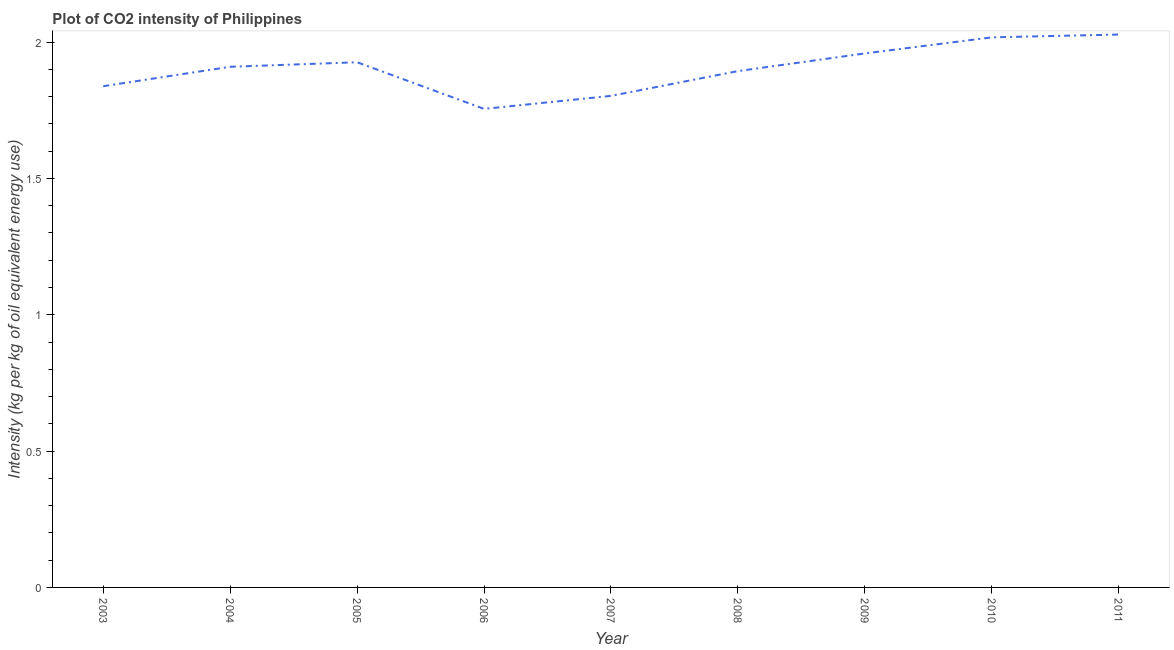What is the co2 intensity in 2010?
Your response must be concise. 2.02. Across all years, what is the maximum co2 intensity?
Make the answer very short. 2.03. Across all years, what is the minimum co2 intensity?
Offer a terse response. 1.76. In which year was the co2 intensity maximum?
Your response must be concise. 2011. In which year was the co2 intensity minimum?
Keep it short and to the point. 2006. What is the sum of the co2 intensity?
Make the answer very short. 17.13. What is the difference between the co2 intensity in 2003 and 2008?
Keep it short and to the point. -0.06. What is the average co2 intensity per year?
Make the answer very short. 1.9. What is the median co2 intensity?
Keep it short and to the point. 1.91. In how many years, is the co2 intensity greater than 0.4 kg?
Your response must be concise. 9. What is the ratio of the co2 intensity in 2003 to that in 2008?
Offer a terse response. 0.97. Is the difference between the co2 intensity in 2005 and 2006 greater than the difference between any two years?
Your response must be concise. No. What is the difference between the highest and the second highest co2 intensity?
Make the answer very short. 0.01. What is the difference between the highest and the lowest co2 intensity?
Make the answer very short. 0.27. In how many years, is the co2 intensity greater than the average co2 intensity taken over all years?
Your response must be concise. 5. Does the co2 intensity monotonically increase over the years?
Offer a terse response. No. Are the values on the major ticks of Y-axis written in scientific E-notation?
Offer a very short reply. No. Does the graph contain grids?
Your response must be concise. No. What is the title of the graph?
Your response must be concise. Plot of CO2 intensity of Philippines. What is the label or title of the X-axis?
Offer a terse response. Year. What is the label or title of the Y-axis?
Make the answer very short. Intensity (kg per kg of oil equivalent energy use). What is the Intensity (kg per kg of oil equivalent energy use) of 2003?
Make the answer very short. 1.84. What is the Intensity (kg per kg of oil equivalent energy use) of 2004?
Provide a short and direct response. 1.91. What is the Intensity (kg per kg of oil equivalent energy use) of 2005?
Give a very brief answer. 1.93. What is the Intensity (kg per kg of oil equivalent energy use) in 2006?
Offer a terse response. 1.76. What is the Intensity (kg per kg of oil equivalent energy use) of 2007?
Offer a terse response. 1.8. What is the Intensity (kg per kg of oil equivalent energy use) of 2008?
Provide a succinct answer. 1.89. What is the Intensity (kg per kg of oil equivalent energy use) in 2009?
Your answer should be very brief. 1.96. What is the Intensity (kg per kg of oil equivalent energy use) in 2010?
Provide a succinct answer. 2.02. What is the Intensity (kg per kg of oil equivalent energy use) of 2011?
Offer a terse response. 2.03. What is the difference between the Intensity (kg per kg of oil equivalent energy use) in 2003 and 2004?
Your answer should be compact. -0.07. What is the difference between the Intensity (kg per kg of oil equivalent energy use) in 2003 and 2005?
Make the answer very short. -0.09. What is the difference between the Intensity (kg per kg of oil equivalent energy use) in 2003 and 2006?
Your answer should be compact. 0.08. What is the difference between the Intensity (kg per kg of oil equivalent energy use) in 2003 and 2007?
Your answer should be compact. 0.04. What is the difference between the Intensity (kg per kg of oil equivalent energy use) in 2003 and 2008?
Provide a succinct answer. -0.06. What is the difference between the Intensity (kg per kg of oil equivalent energy use) in 2003 and 2009?
Offer a terse response. -0.12. What is the difference between the Intensity (kg per kg of oil equivalent energy use) in 2003 and 2010?
Your answer should be very brief. -0.18. What is the difference between the Intensity (kg per kg of oil equivalent energy use) in 2003 and 2011?
Provide a succinct answer. -0.19. What is the difference between the Intensity (kg per kg of oil equivalent energy use) in 2004 and 2005?
Your response must be concise. -0.02. What is the difference between the Intensity (kg per kg of oil equivalent energy use) in 2004 and 2006?
Your answer should be very brief. 0.15. What is the difference between the Intensity (kg per kg of oil equivalent energy use) in 2004 and 2007?
Your answer should be very brief. 0.11. What is the difference between the Intensity (kg per kg of oil equivalent energy use) in 2004 and 2008?
Your response must be concise. 0.02. What is the difference between the Intensity (kg per kg of oil equivalent energy use) in 2004 and 2009?
Keep it short and to the point. -0.05. What is the difference between the Intensity (kg per kg of oil equivalent energy use) in 2004 and 2010?
Your response must be concise. -0.11. What is the difference between the Intensity (kg per kg of oil equivalent energy use) in 2004 and 2011?
Your response must be concise. -0.12. What is the difference between the Intensity (kg per kg of oil equivalent energy use) in 2005 and 2006?
Your answer should be compact. 0.17. What is the difference between the Intensity (kg per kg of oil equivalent energy use) in 2005 and 2007?
Keep it short and to the point. 0.12. What is the difference between the Intensity (kg per kg of oil equivalent energy use) in 2005 and 2008?
Your response must be concise. 0.03. What is the difference between the Intensity (kg per kg of oil equivalent energy use) in 2005 and 2009?
Make the answer very short. -0.03. What is the difference between the Intensity (kg per kg of oil equivalent energy use) in 2005 and 2010?
Offer a very short reply. -0.09. What is the difference between the Intensity (kg per kg of oil equivalent energy use) in 2005 and 2011?
Provide a succinct answer. -0.1. What is the difference between the Intensity (kg per kg of oil equivalent energy use) in 2006 and 2007?
Ensure brevity in your answer.  -0.05. What is the difference between the Intensity (kg per kg of oil equivalent energy use) in 2006 and 2008?
Keep it short and to the point. -0.14. What is the difference between the Intensity (kg per kg of oil equivalent energy use) in 2006 and 2009?
Give a very brief answer. -0.2. What is the difference between the Intensity (kg per kg of oil equivalent energy use) in 2006 and 2010?
Your answer should be compact. -0.26. What is the difference between the Intensity (kg per kg of oil equivalent energy use) in 2006 and 2011?
Ensure brevity in your answer.  -0.27. What is the difference between the Intensity (kg per kg of oil equivalent energy use) in 2007 and 2008?
Offer a terse response. -0.09. What is the difference between the Intensity (kg per kg of oil equivalent energy use) in 2007 and 2009?
Make the answer very short. -0.16. What is the difference between the Intensity (kg per kg of oil equivalent energy use) in 2007 and 2010?
Provide a short and direct response. -0.21. What is the difference between the Intensity (kg per kg of oil equivalent energy use) in 2007 and 2011?
Your answer should be compact. -0.22. What is the difference between the Intensity (kg per kg of oil equivalent energy use) in 2008 and 2009?
Make the answer very short. -0.06. What is the difference between the Intensity (kg per kg of oil equivalent energy use) in 2008 and 2010?
Your response must be concise. -0.12. What is the difference between the Intensity (kg per kg of oil equivalent energy use) in 2008 and 2011?
Provide a short and direct response. -0.13. What is the difference between the Intensity (kg per kg of oil equivalent energy use) in 2009 and 2010?
Offer a very short reply. -0.06. What is the difference between the Intensity (kg per kg of oil equivalent energy use) in 2009 and 2011?
Your answer should be very brief. -0.07. What is the difference between the Intensity (kg per kg of oil equivalent energy use) in 2010 and 2011?
Ensure brevity in your answer.  -0.01. What is the ratio of the Intensity (kg per kg of oil equivalent energy use) in 2003 to that in 2004?
Your answer should be compact. 0.96. What is the ratio of the Intensity (kg per kg of oil equivalent energy use) in 2003 to that in 2005?
Your response must be concise. 0.95. What is the ratio of the Intensity (kg per kg of oil equivalent energy use) in 2003 to that in 2006?
Provide a short and direct response. 1.05. What is the ratio of the Intensity (kg per kg of oil equivalent energy use) in 2003 to that in 2007?
Your response must be concise. 1.02. What is the ratio of the Intensity (kg per kg of oil equivalent energy use) in 2003 to that in 2009?
Provide a short and direct response. 0.94. What is the ratio of the Intensity (kg per kg of oil equivalent energy use) in 2003 to that in 2010?
Keep it short and to the point. 0.91. What is the ratio of the Intensity (kg per kg of oil equivalent energy use) in 2003 to that in 2011?
Make the answer very short. 0.91. What is the ratio of the Intensity (kg per kg of oil equivalent energy use) in 2004 to that in 2005?
Provide a succinct answer. 0.99. What is the ratio of the Intensity (kg per kg of oil equivalent energy use) in 2004 to that in 2006?
Offer a terse response. 1.09. What is the ratio of the Intensity (kg per kg of oil equivalent energy use) in 2004 to that in 2007?
Your answer should be compact. 1.06. What is the ratio of the Intensity (kg per kg of oil equivalent energy use) in 2004 to that in 2008?
Offer a terse response. 1.01. What is the ratio of the Intensity (kg per kg of oil equivalent energy use) in 2004 to that in 2010?
Keep it short and to the point. 0.95. What is the ratio of the Intensity (kg per kg of oil equivalent energy use) in 2004 to that in 2011?
Provide a succinct answer. 0.94. What is the ratio of the Intensity (kg per kg of oil equivalent energy use) in 2005 to that in 2006?
Your response must be concise. 1.1. What is the ratio of the Intensity (kg per kg of oil equivalent energy use) in 2005 to that in 2007?
Keep it short and to the point. 1.07. What is the ratio of the Intensity (kg per kg of oil equivalent energy use) in 2005 to that in 2008?
Provide a short and direct response. 1.02. What is the ratio of the Intensity (kg per kg of oil equivalent energy use) in 2005 to that in 2009?
Ensure brevity in your answer.  0.98. What is the ratio of the Intensity (kg per kg of oil equivalent energy use) in 2005 to that in 2010?
Give a very brief answer. 0.95. What is the ratio of the Intensity (kg per kg of oil equivalent energy use) in 2006 to that in 2008?
Provide a succinct answer. 0.93. What is the ratio of the Intensity (kg per kg of oil equivalent energy use) in 2006 to that in 2009?
Your answer should be compact. 0.9. What is the ratio of the Intensity (kg per kg of oil equivalent energy use) in 2006 to that in 2010?
Keep it short and to the point. 0.87. What is the ratio of the Intensity (kg per kg of oil equivalent energy use) in 2006 to that in 2011?
Make the answer very short. 0.87. What is the ratio of the Intensity (kg per kg of oil equivalent energy use) in 2007 to that in 2009?
Your response must be concise. 0.92. What is the ratio of the Intensity (kg per kg of oil equivalent energy use) in 2007 to that in 2010?
Give a very brief answer. 0.89. What is the ratio of the Intensity (kg per kg of oil equivalent energy use) in 2007 to that in 2011?
Ensure brevity in your answer.  0.89. What is the ratio of the Intensity (kg per kg of oil equivalent energy use) in 2008 to that in 2009?
Your answer should be compact. 0.97. What is the ratio of the Intensity (kg per kg of oil equivalent energy use) in 2008 to that in 2010?
Give a very brief answer. 0.94. What is the ratio of the Intensity (kg per kg of oil equivalent energy use) in 2008 to that in 2011?
Your answer should be very brief. 0.93. What is the ratio of the Intensity (kg per kg of oil equivalent energy use) in 2009 to that in 2011?
Offer a terse response. 0.97. 